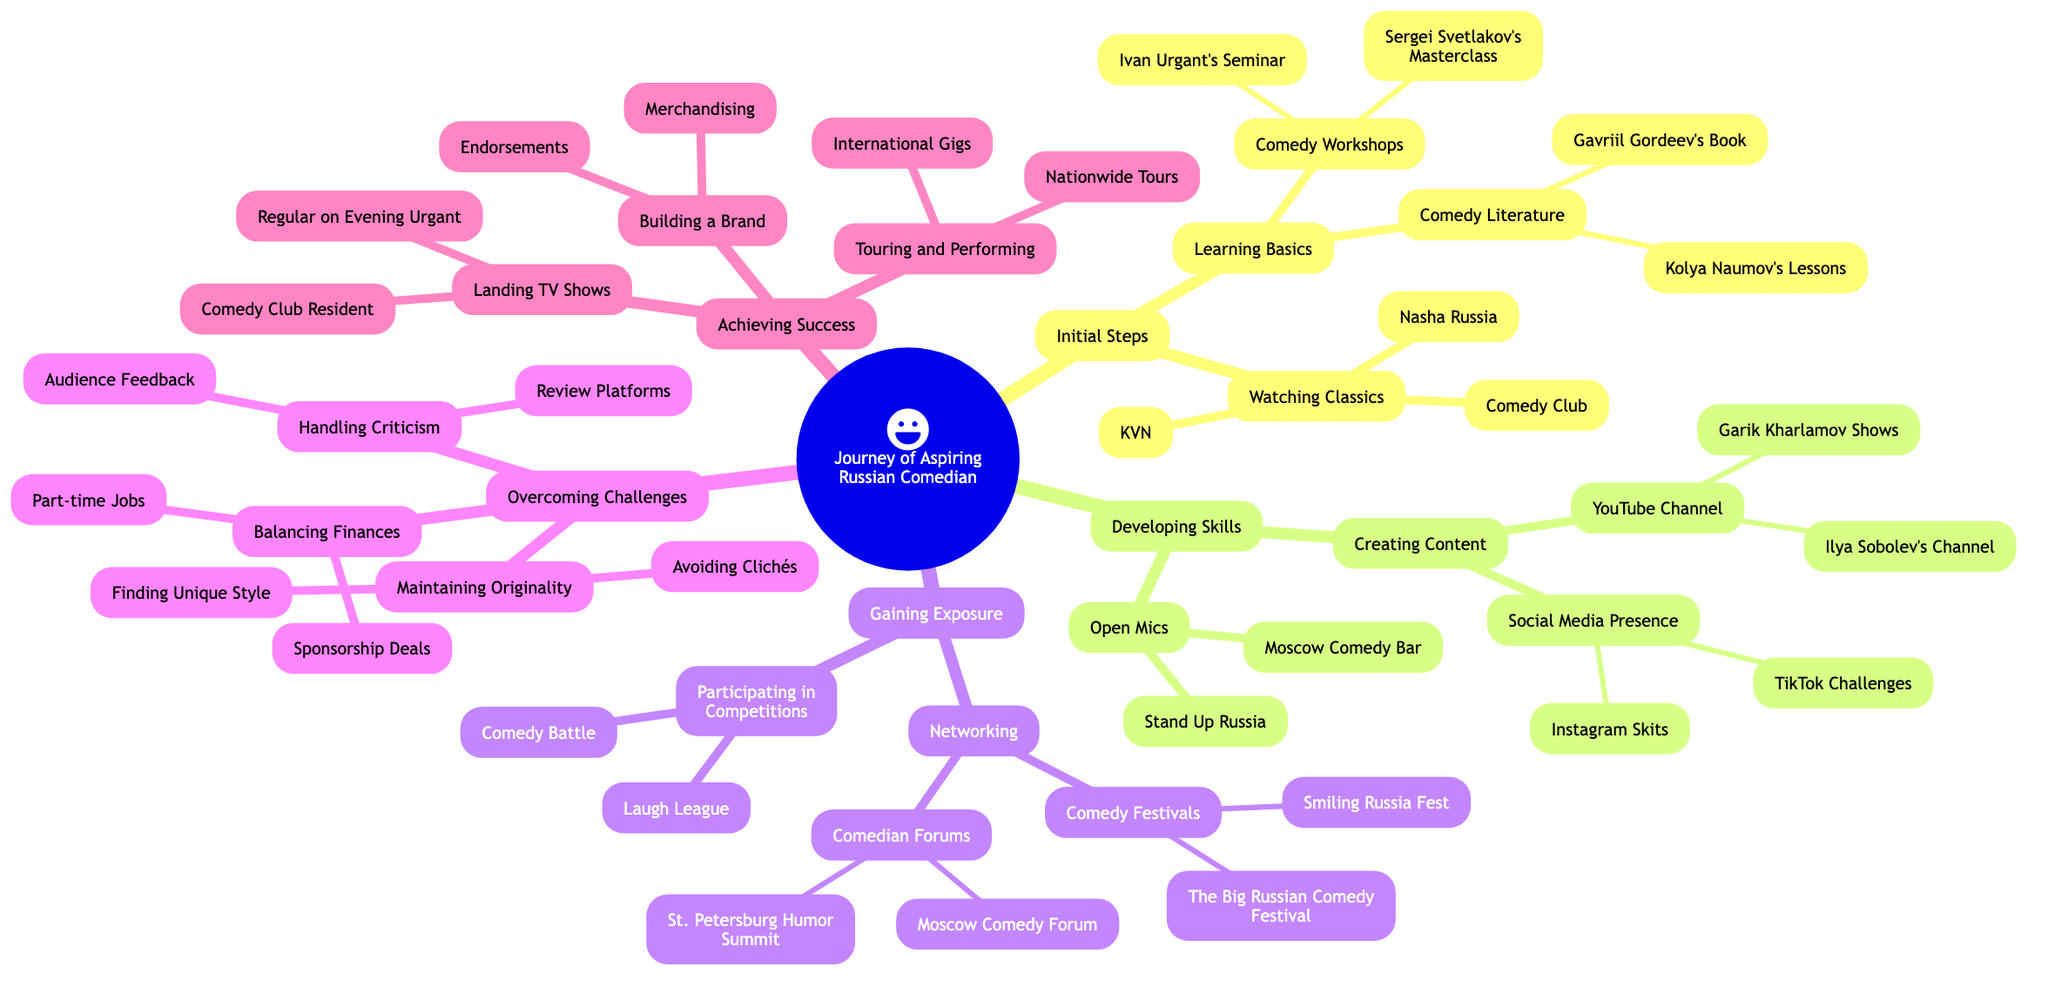What are the two main categories under 'Initial Steps'? "Initial Steps" has two main branches which are "Watching Classics" and "Learning Basics". These categories summarize the activities new comedians should focus on at the beginning of their journey.
Answer: Watching Classics, Learning Basics How many workshops are listed under 'Learning Basics'? Under "Learning Basics", there are two subcategories: "Comedy Literature" and "Comedy Workshops". "Comedy Workshops" has two entries: "Ivan Urgant’s Seminar" and "Sergei Svetlakov's Masterclass", totaling 2 workshops.
Answer: 2 What is the last node under 'Achieving Success'? The sequenced categories under "Achieving Success" include "Landing TV Shows", "Touring and Performing", and "Building a Brand", with "Endorsements" being the last node in this section.
Answer: Endorsements How does 'Gaining Exposure' connect to 'Achieving Success'? "Gaining Exposure" encompasses two main areas: "Participating in Competitions" and "Networking". Successfully engaging in these activities can lead to the "Achieving Success" stage, indicating that exposure is a prerequisite for success in comedy.
Answer: Exposure leads to success What are the two platforms mentioned under 'Creating Content'? Under "Creating Content", there are two primary branches: "YouTube Channel" and "Social Media Presence", and these represent the platforms comedians should use to promote their content.
Answer: YouTube Channel, Social Media Presence Which festival is mentioned under 'Networking'? "Networking" includes a category called "Comedy Festivals", which lists two festivals: "The Big Russian Comedy Festival" and "Smiling Russia Fest". Thus, one of the festivals under this category is "The Big Russian Comedy Festival".
Answer: The Big Russian Comedy Festival What is one challenge discussed in 'Overcoming Challenges'? The section on "Overcoming Challenges" includes "Handling Criticism", "Balancing Finances", and "Maintaining Originality". One of the challenges is "Handling Criticism".
Answer: Handling Criticism How many nodes are under 'Developing Skills'? "Developing Skills" has two primary branches: "Open Mics" and "Creating Content". Each of these branches contains sub-nodes, with "Open Mics" having 2 nodes and "Creating Content" having 2 nodes as well, totaling 4 nodes under "Developing Skills".
Answer: 4 